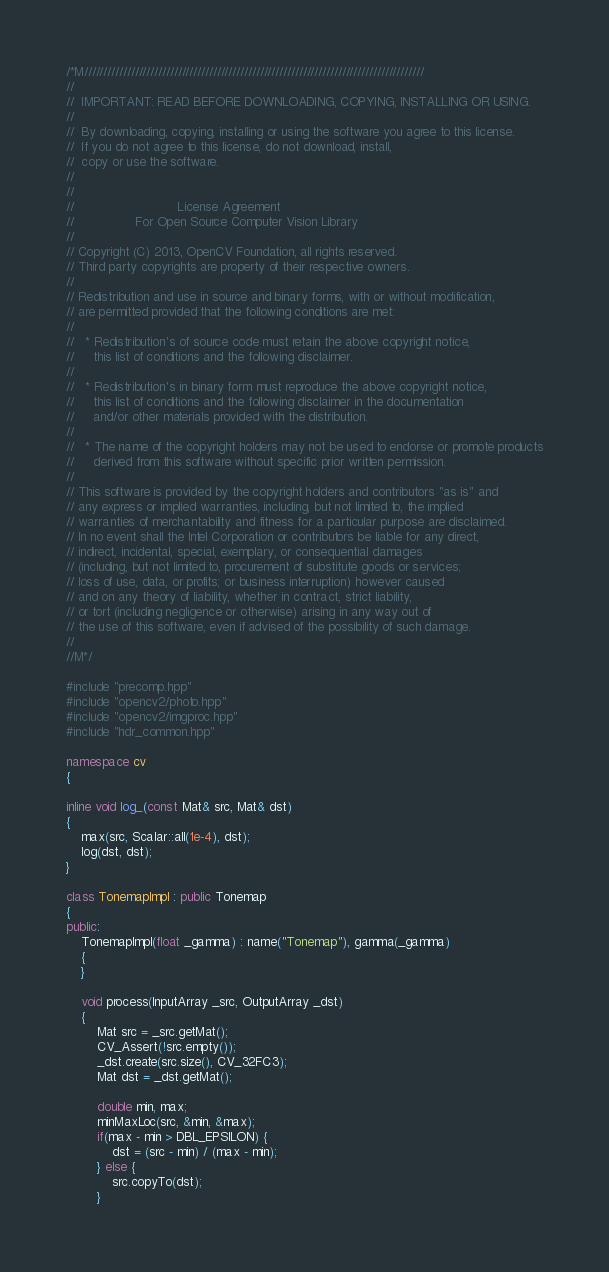Convert code to text. <code><loc_0><loc_0><loc_500><loc_500><_C++_>/*M///////////////////////////////////////////////////////////////////////////////////////
//
//  IMPORTANT: READ BEFORE DOWNLOADING, COPYING, INSTALLING OR USING.
//
//  By downloading, copying, installing or using the software you agree to this license.
//  If you do not agree to this license, do not download, install,
//  copy or use the software.
//
//
//                           License Agreement
//                For Open Source Computer Vision Library
//
// Copyright (C) 2013, OpenCV Foundation, all rights reserved.
// Third party copyrights are property of their respective owners.
//
// Redistribution and use in source and binary forms, with or without modification,
// are permitted provided that the following conditions are met:
//
//   * Redistribution's of source code must retain the above copyright notice,
//     this list of conditions and the following disclaimer.
//
//   * Redistribution's in binary form must reproduce the above copyright notice,
//     this list of conditions and the following disclaimer in the documentation
//     and/or other materials provided with the distribution.
//
//   * The name of the copyright holders may not be used to endorse or promote products
//     derived from this software without specific prior written permission.
//
// This software is provided by the copyright holders and contributors "as is" and
// any express or implied warranties, including, but not limited to, the implied
// warranties of merchantability and fitness for a particular purpose are disclaimed.
// In no event shall the Intel Corporation or contributors be liable for any direct,
// indirect, incidental, special, exemplary, or consequential damages
// (including, but not limited to, procurement of substitute goods or services;
// loss of use, data, or profits; or business interruption) however caused
// and on any theory of liability, whether in contract, strict liability,
// or tort (including negligence or otherwise) arising in any way out of
// the use of this software, even if advised of the possibility of such damage.
//
//M*/

#include "precomp.hpp"
#include "opencv2/photo.hpp"
#include "opencv2/imgproc.hpp"
#include "hdr_common.hpp"

namespace cv
{

inline void log_(const Mat& src, Mat& dst)
{
    max(src, Scalar::all(1e-4), dst);
    log(dst, dst);
}

class TonemapImpl : public Tonemap
{
public:
    TonemapImpl(float _gamma) : name("Tonemap"), gamma(_gamma)
    {
    }

    void process(InputArray _src, OutputArray _dst)
    {
        Mat src = _src.getMat();
        CV_Assert(!src.empty());
        _dst.create(src.size(), CV_32FC3);
        Mat dst = _dst.getMat();

        double min, max;
        minMaxLoc(src, &min, &max);
        if(max - min > DBL_EPSILON) {
            dst = (src - min) / (max - min);
        } else {
            src.copyTo(dst);
        }
</code> 